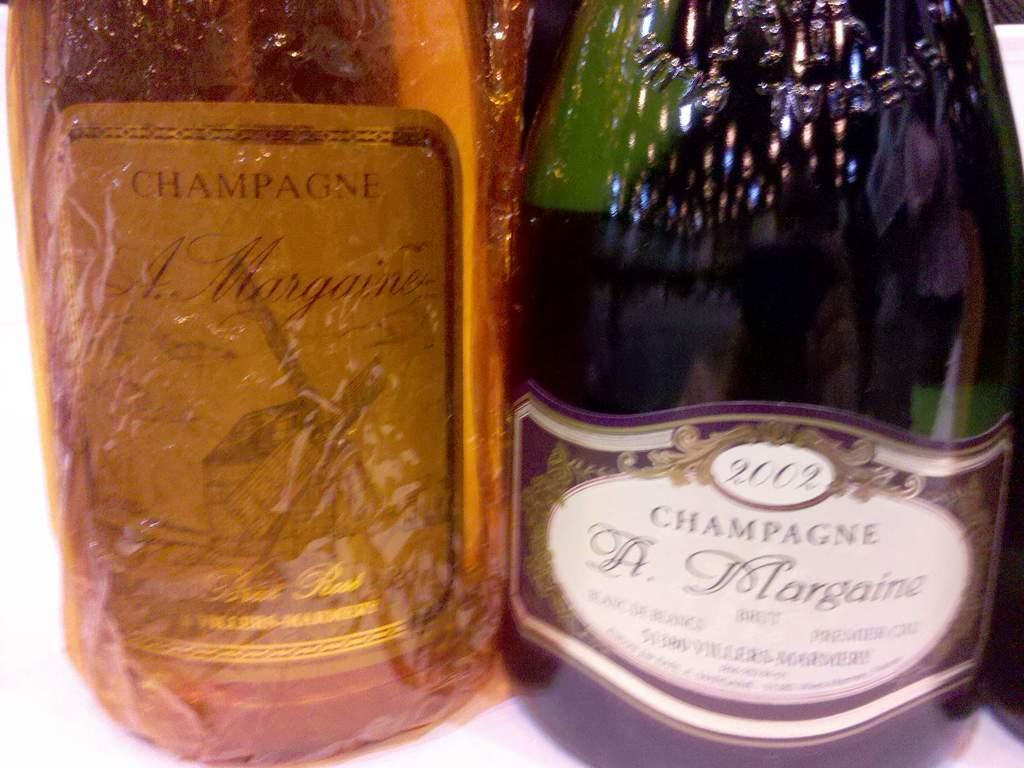<image>
Offer a succinct explanation of the picture presented. Two bottles, one of which has the word champagne on the front. 